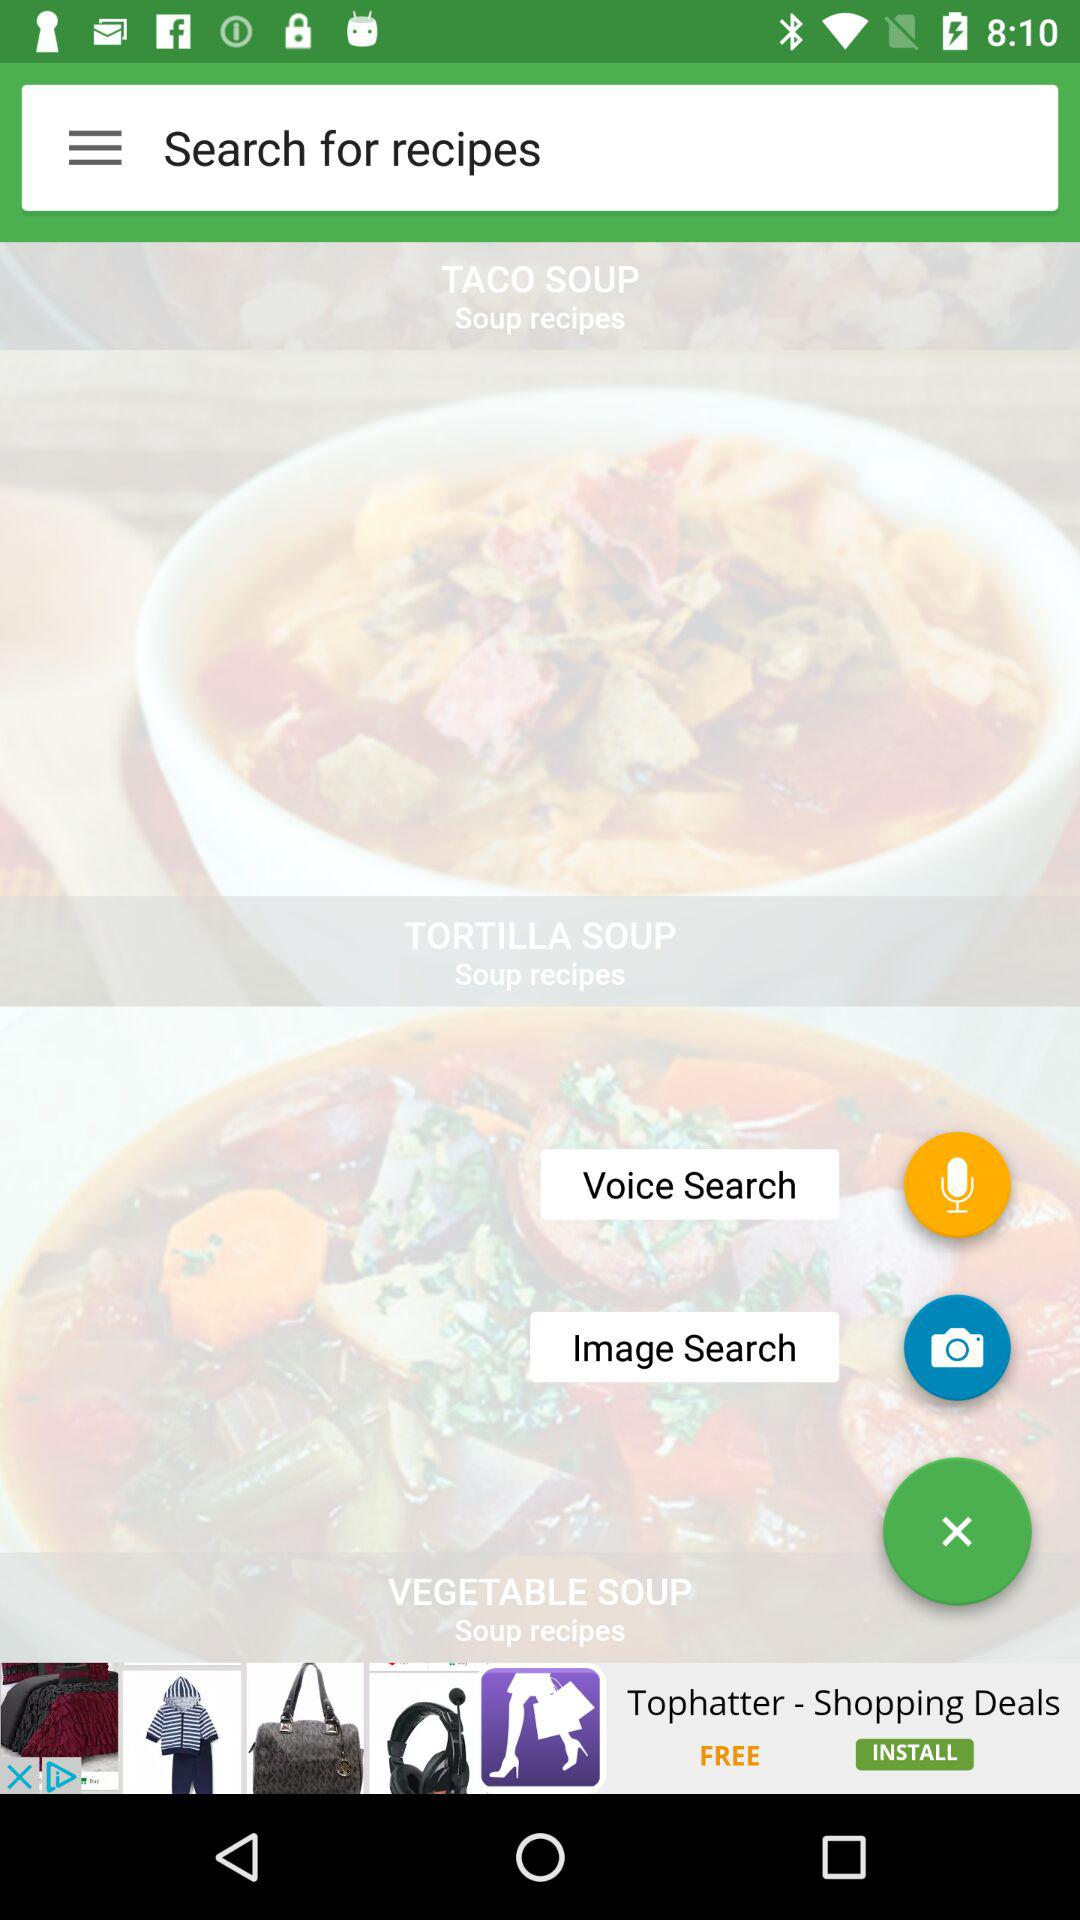How many soup recipes are there?
Answer the question using a single word or phrase. 3 